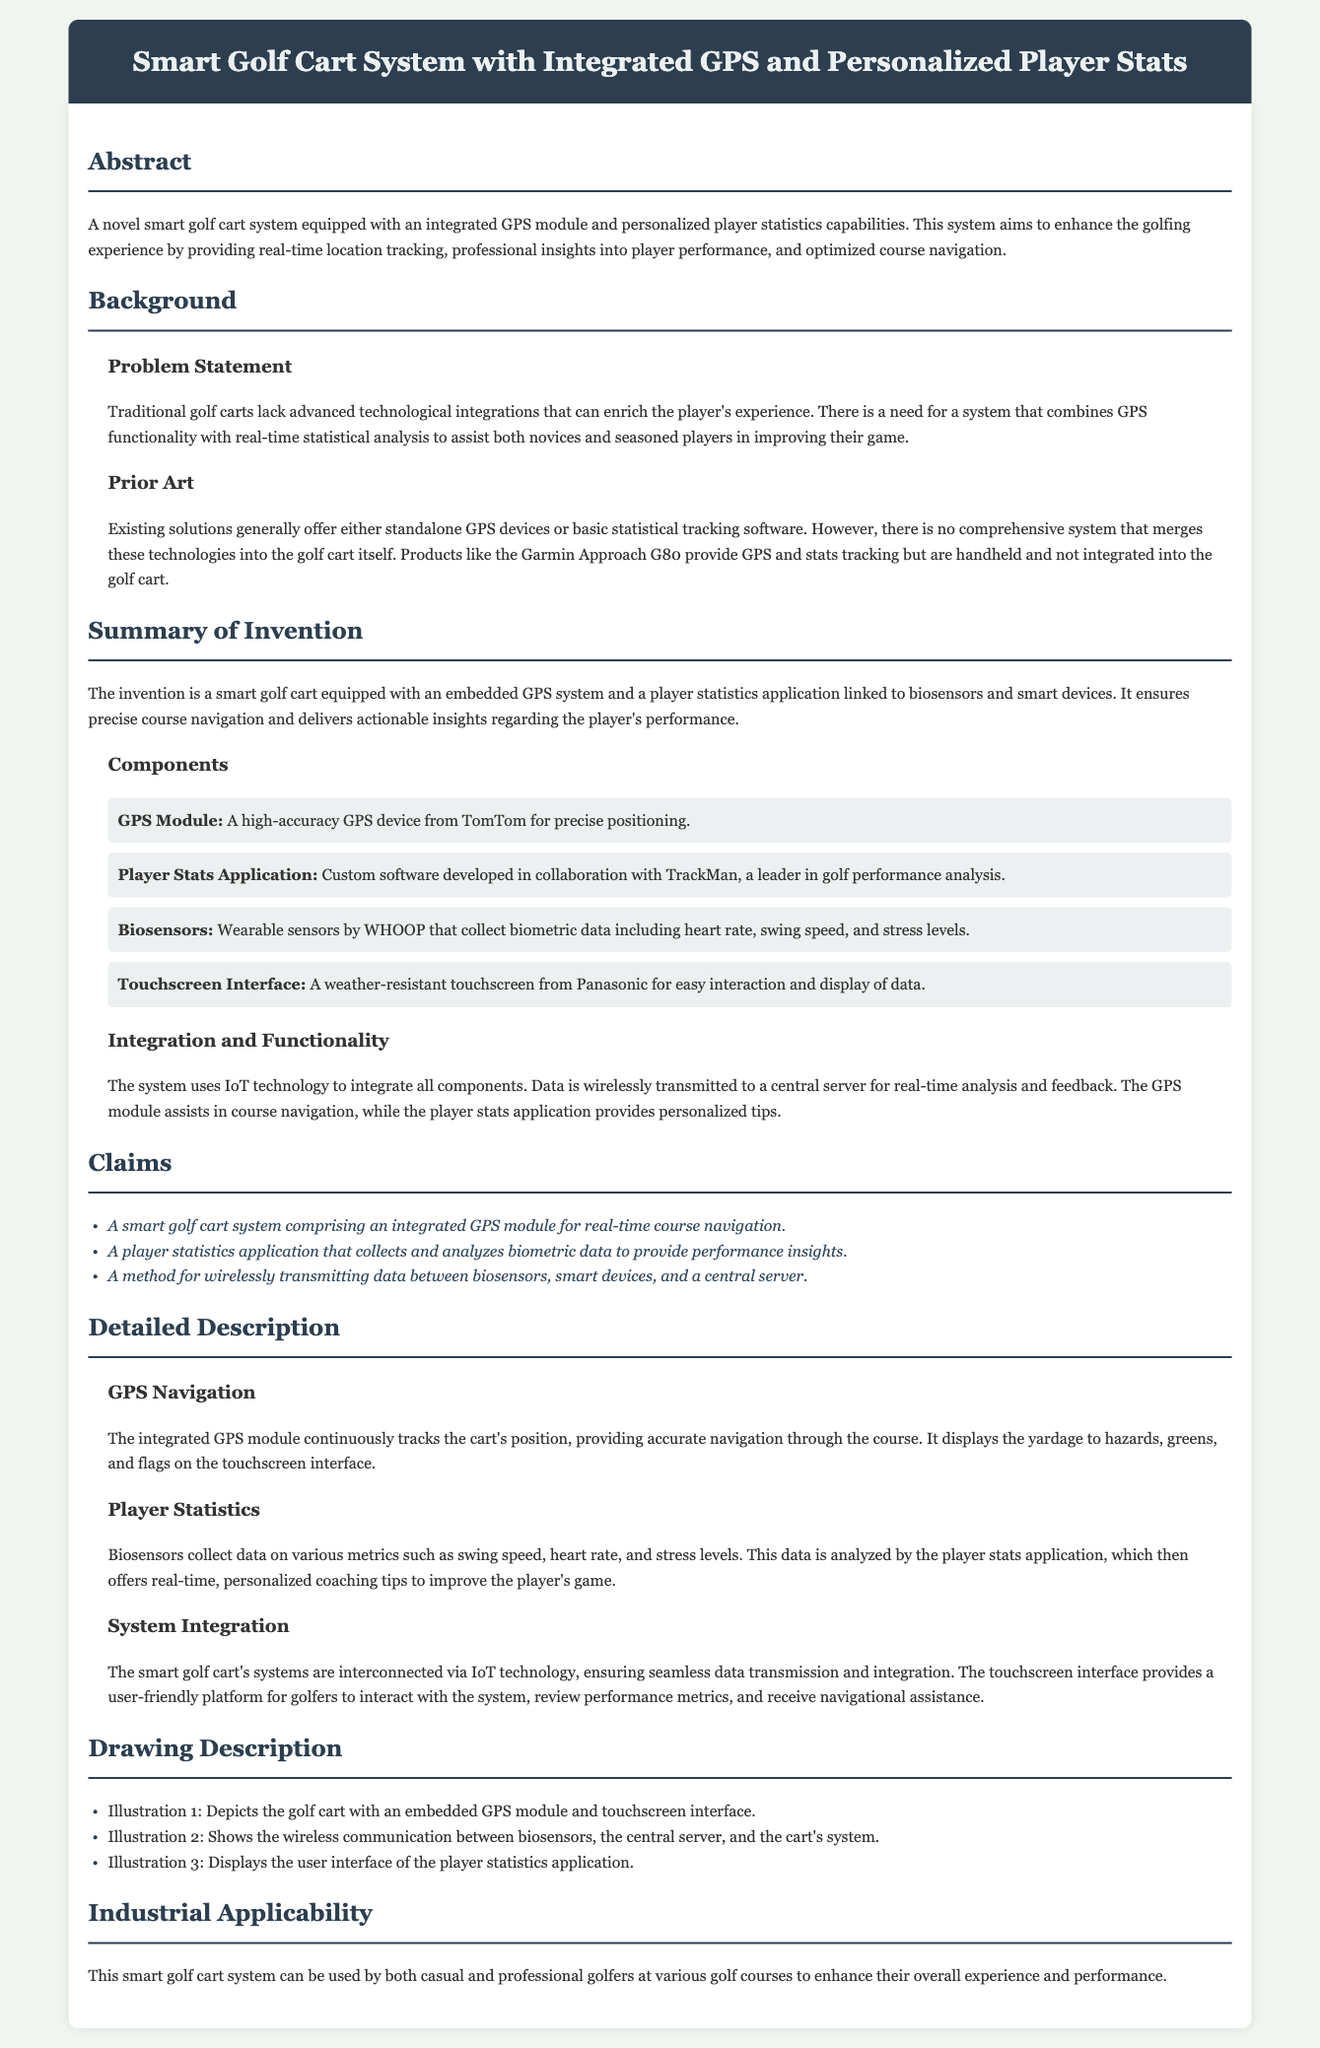what is the title of the patent application? The title of the patent application is found in the header section of the document.
Answer: Smart Golf Cart System with Integrated GPS and Personalized Player Stats who collaborated with TrackMan for the player stats application? The document mentions collaboration with TrackMan specifically for the player statistics application.
Answer: Custom software which company provides the GPS module? The specific company that provides the GPS module is mentioned in the components section of the document.
Answer: TomTom what technology is used for data transmission in the system? The document states that IoT technology is utilized for integrating various components of the smart golf cart.
Answer: IoT how many illustrations are described in the drawing description? The number of illustrations in the drawing description can be found in the related section detailing the illustrations present.
Answer: Three what type of data do the biosensors collect? The biosensors collect various metrics, as described in the player statistics subsection.
Answer: Biometric data what advantage does the smart golf cart system provide? The advantages presented in the document relate to enhancing the golfing experience and performance.
Answer: Real-time insights what is the purpose of the touchscreen interface? The touchscreen interface's function is explained in the system integration subsection of the document.
Answer: User interaction and data display 